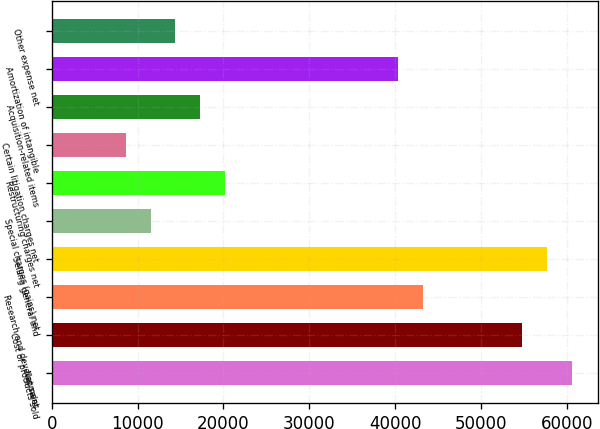Convert chart to OTSL. <chart><loc_0><loc_0><loc_500><loc_500><bar_chart><fcel>Net sales<fcel>Cost of products sold<fcel>Research and development<fcel>Selling general and<fcel>Special charges (gains) net<fcel>Restructuring charges net<fcel>Certain litigation charges net<fcel>Acquisition-related items<fcel>Amortization of intangible<fcel>Other expense net<nl><fcel>60547.7<fcel>54781.4<fcel>43248.8<fcel>57664.5<fcel>11534.1<fcel>20183.6<fcel>8650.97<fcel>17300.4<fcel>40365.6<fcel>14417.3<nl></chart> 